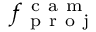<formula> <loc_0><loc_0><loc_500><loc_500>f _ { p r o j } ^ { c a m }</formula> 